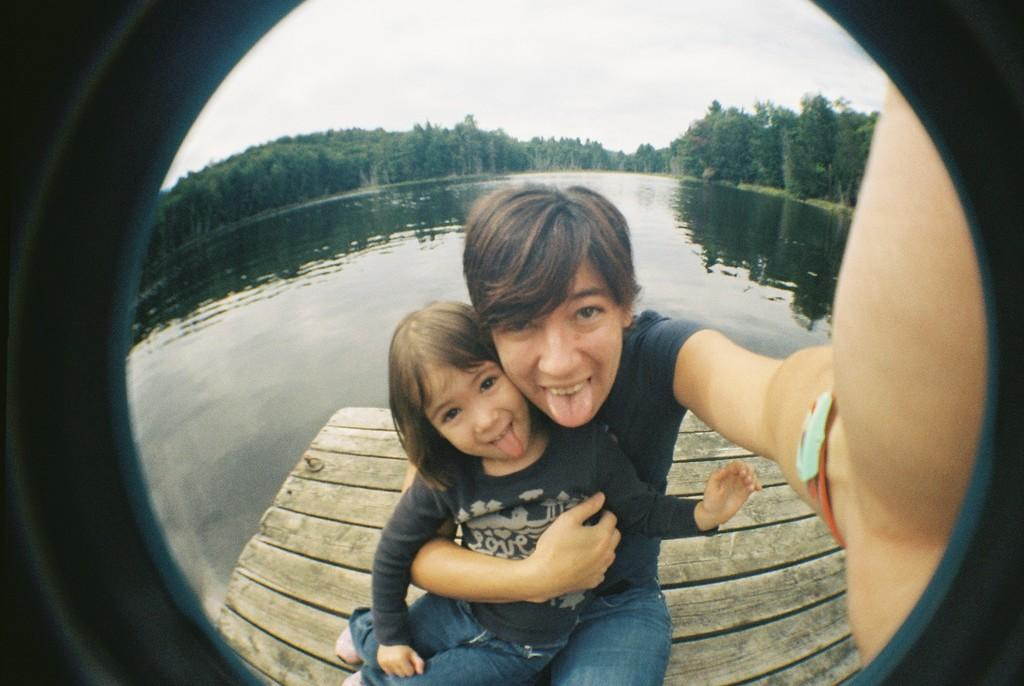Who are the people in the image? There is a woman and a girl in the image. What are the woman and the girl doing in the image? The woman and the girl are seated on a wooden plank. What can be seen in the background of the image? There is water and trees visible in the background of the image. What type of badge is the woman wearing in the image? There is no badge visible on the woman in the image. What kind of work is the girl doing in the image? The image does not show the girl doing any work; she is simply seated on the wooden plank with the woman. 